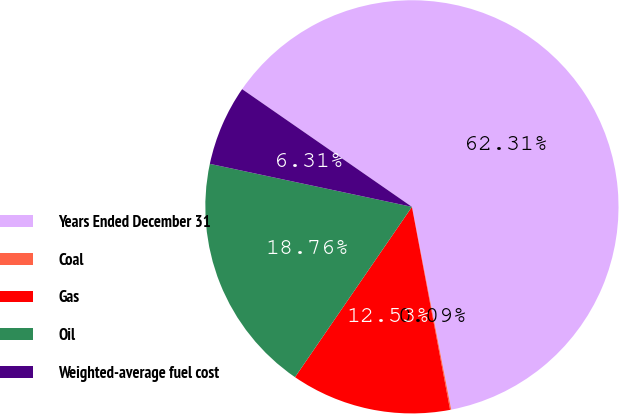<chart> <loc_0><loc_0><loc_500><loc_500><pie_chart><fcel>Years Ended December 31<fcel>Coal<fcel>Gas<fcel>Oil<fcel>Weighted-average fuel cost<nl><fcel>62.3%<fcel>0.09%<fcel>12.53%<fcel>18.76%<fcel>6.31%<nl></chart> 